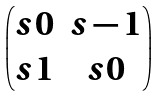<formula> <loc_0><loc_0><loc_500><loc_500>\begin{pmatrix} s { 0 } & s - 1 \\ s 1 & s 0 \end{pmatrix}</formula> 